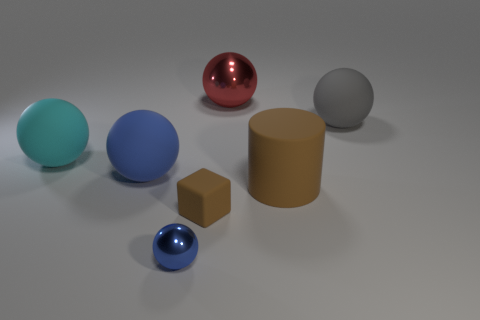What number of other objects are the same color as the large cylinder?
Provide a short and direct response. 1. What material is the cube that is the same color as the cylinder?
Offer a very short reply. Rubber. There is a metallic ball that is in front of the red sphere; is it the same size as the brown cube?
Your answer should be compact. Yes. What is the color of the other shiny thing that is the same shape as the tiny shiny object?
Ensure brevity in your answer.  Red. The metallic object that is in front of the shiny ball behind the metallic thing in front of the red metallic thing is what shape?
Make the answer very short. Sphere. Is the shape of the big cyan thing the same as the big blue matte thing?
Your answer should be compact. Yes. The big red object that is behind the gray matte ball that is in front of the large red metallic ball is what shape?
Make the answer very short. Sphere. Are there any tiny purple metal blocks?
Your answer should be very brief. No. There is a metallic ball on the right side of the metallic ball in front of the large shiny object; what number of rubber blocks are in front of it?
Your answer should be compact. 1. Is the shape of the gray rubber thing the same as the metal thing on the left side of the big red metallic thing?
Your answer should be very brief. Yes. 